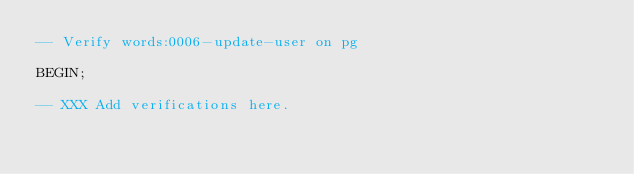Convert code to text. <code><loc_0><loc_0><loc_500><loc_500><_SQL_>-- Verify words:0006-update-user on pg

BEGIN;

-- XXX Add verifications here.
</code> 